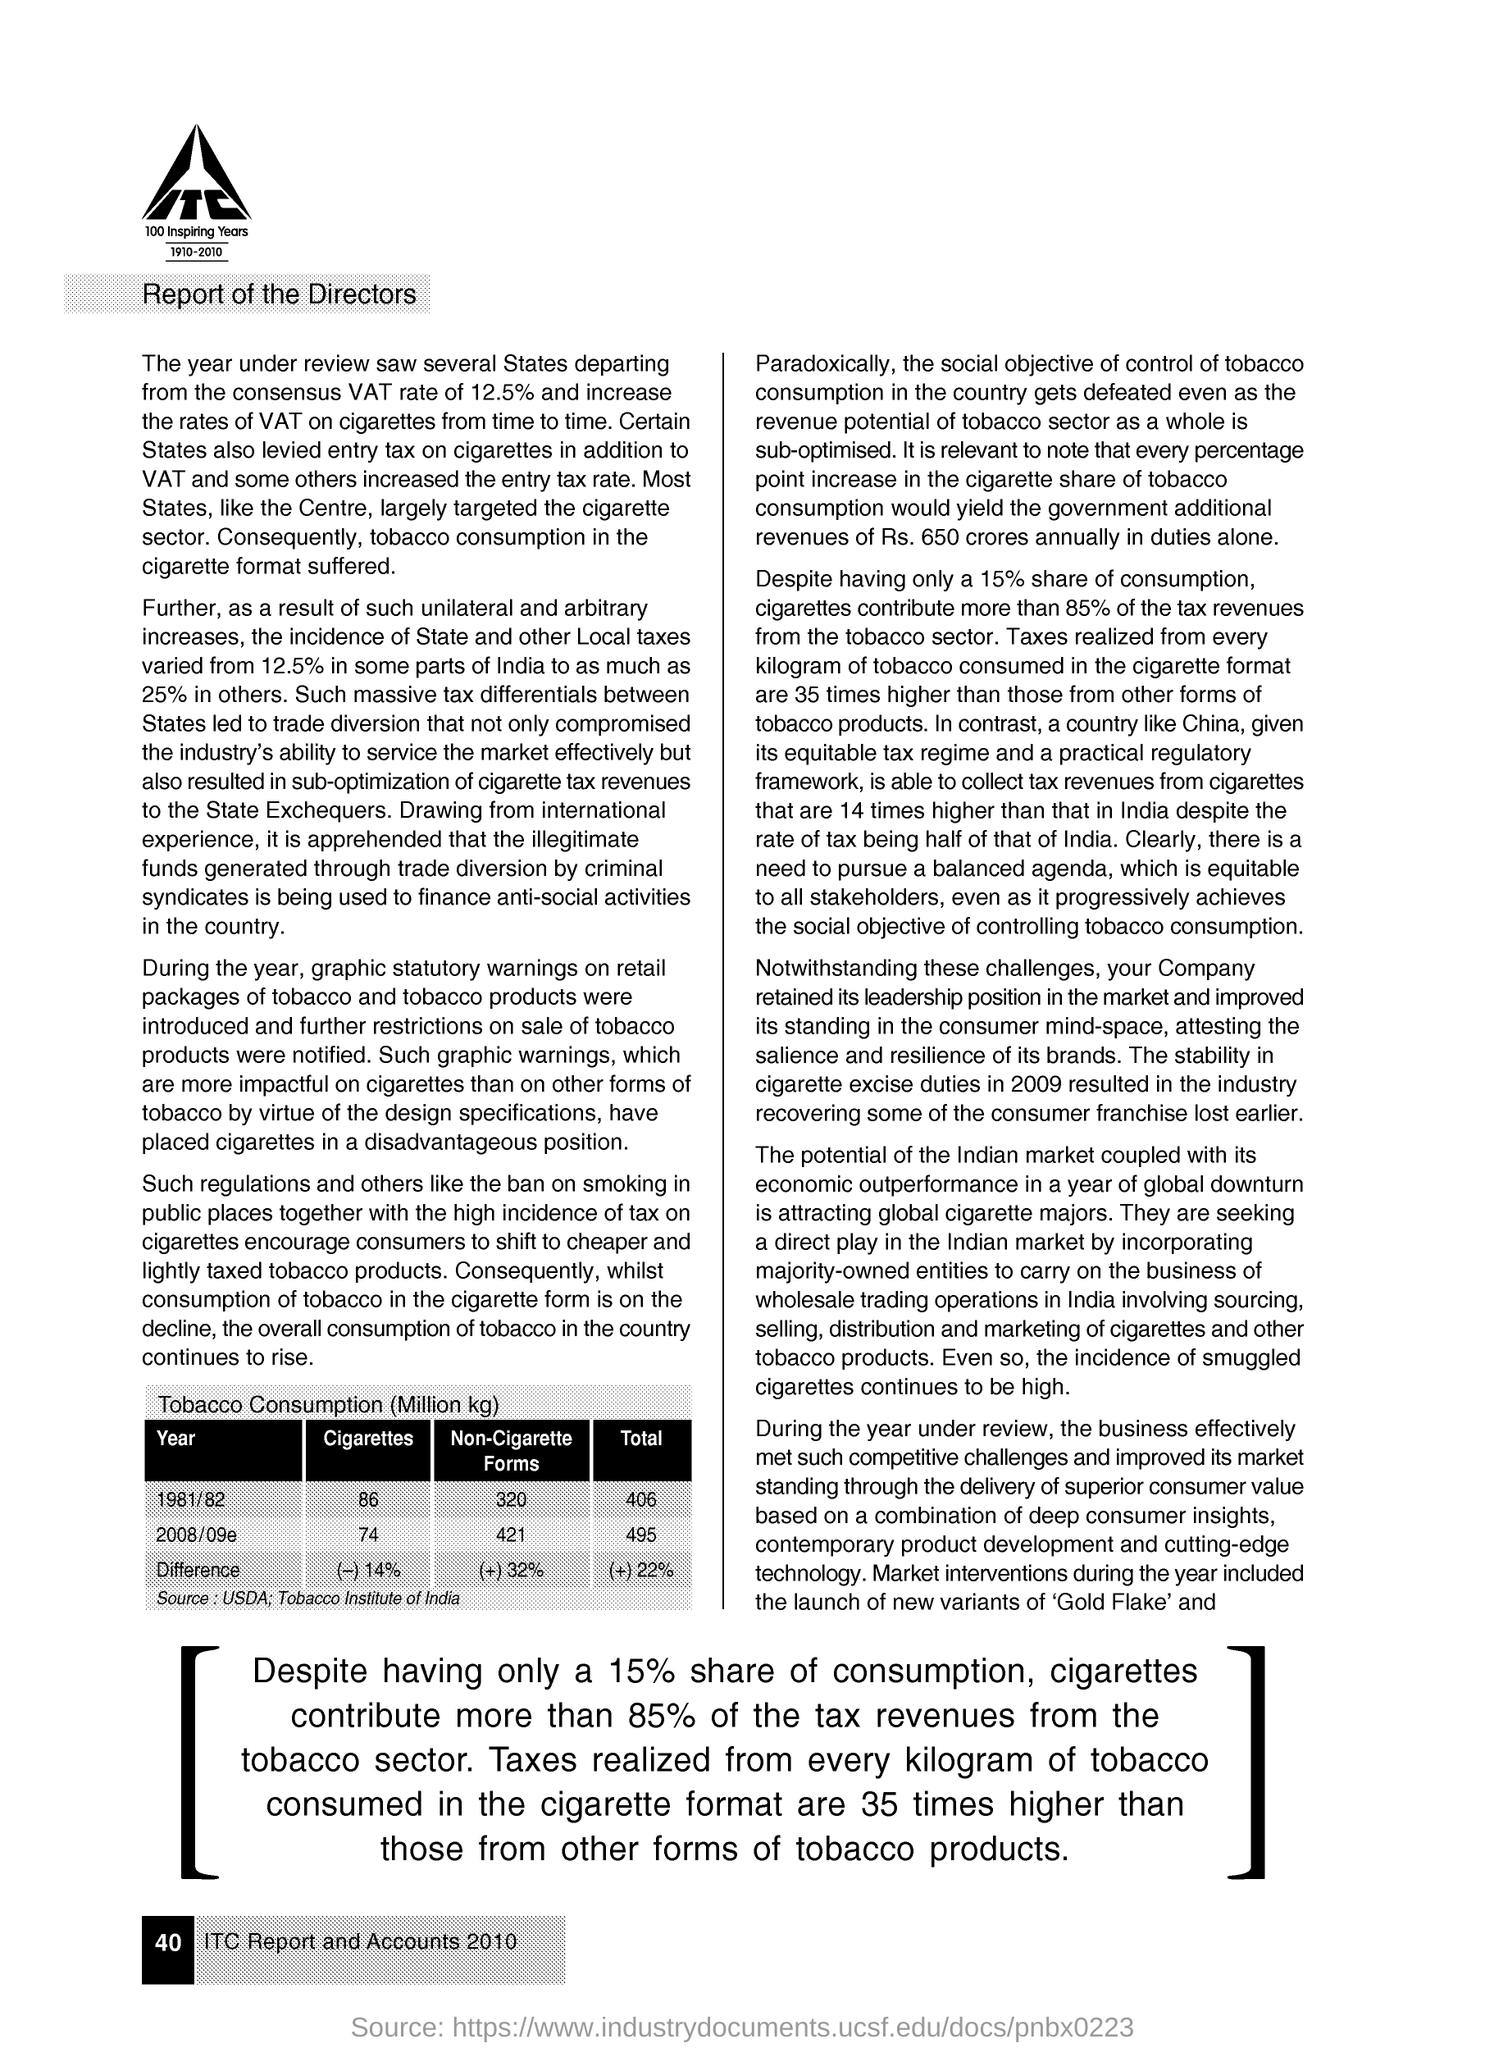How much difference is mentioned for cigarettes consumption?
Your answer should be compact. (-) 14%. How much difference is mentioned for non cigarette forms consumption?
Keep it short and to the point. (+) 32%. 